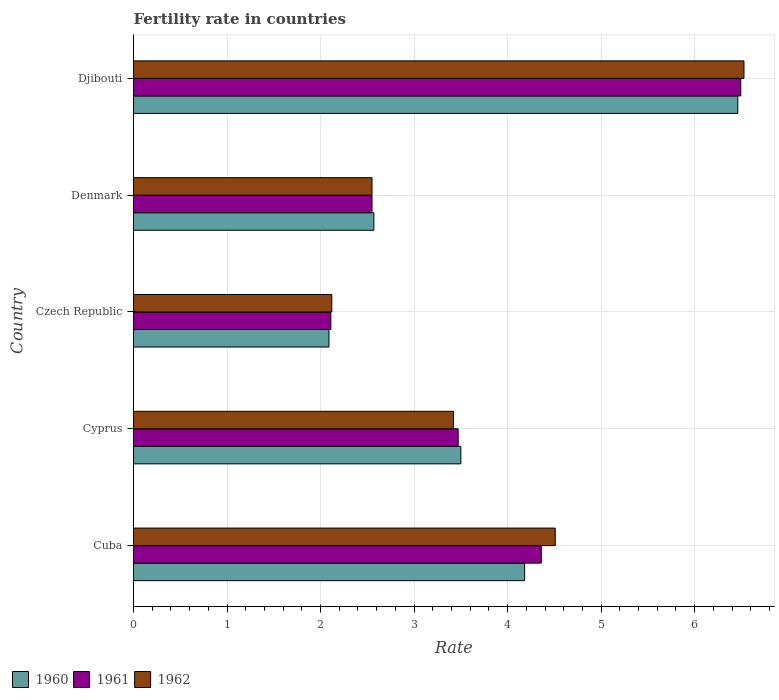Are the number of bars on each tick of the Y-axis equal?
Give a very brief answer. Yes. How many bars are there on the 5th tick from the bottom?
Make the answer very short. 3. What is the label of the 4th group of bars from the top?
Offer a very short reply. Cyprus. In how many cases, is the number of bars for a given country not equal to the number of legend labels?
Your answer should be very brief. 0. What is the fertility rate in 1960 in Cuba?
Offer a terse response. 4.18. Across all countries, what is the maximum fertility rate in 1960?
Keep it short and to the point. 6.46. Across all countries, what is the minimum fertility rate in 1962?
Your answer should be compact. 2.12. In which country was the fertility rate in 1962 maximum?
Make the answer very short. Djibouti. In which country was the fertility rate in 1962 minimum?
Keep it short and to the point. Czech Republic. What is the total fertility rate in 1962 in the graph?
Your answer should be very brief. 19.13. What is the difference between the fertility rate in 1960 in Cuba and that in Djibouti?
Your answer should be very brief. -2.28. What is the difference between the fertility rate in 1960 in Djibouti and the fertility rate in 1962 in Cyprus?
Offer a very short reply. 3.04. What is the average fertility rate in 1961 per country?
Offer a very short reply. 3.8. What is the difference between the fertility rate in 1961 and fertility rate in 1962 in Cyprus?
Give a very brief answer. 0.05. What is the ratio of the fertility rate in 1960 in Cuba to that in Denmark?
Your response must be concise. 1.63. What is the difference between the highest and the second highest fertility rate in 1962?
Keep it short and to the point. 2.02. What is the difference between the highest and the lowest fertility rate in 1960?
Offer a very short reply. 4.37. Is it the case that in every country, the sum of the fertility rate in 1960 and fertility rate in 1962 is greater than the fertility rate in 1961?
Your answer should be compact. Yes. Are all the bars in the graph horizontal?
Keep it short and to the point. Yes. Are the values on the major ticks of X-axis written in scientific E-notation?
Your response must be concise. No. Does the graph contain any zero values?
Your answer should be compact. No. How are the legend labels stacked?
Your response must be concise. Horizontal. What is the title of the graph?
Your answer should be very brief. Fertility rate in countries. What is the label or title of the X-axis?
Your answer should be very brief. Rate. What is the label or title of the Y-axis?
Your answer should be compact. Country. What is the Rate of 1960 in Cuba?
Keep it short and to the point. 4.18. What is the Rate of 1961 in Cuba?
Give a very brief answer. 4.36. What is the Rate of 1962 in Cuba?
Offer a terse response. 4.51. What is the Rate in 1960 in Cyprus?
Ensure brevity in your answer.  3.5. What is the Rate of 1961 in Cyprus?
Make the answer very short. 3.47. What is the Rate in 1962 in Cyprus?
Provide a succinct answer. 3.42. What is the Rate in 1960 in Czech Republic?
Your answer should be very brief. 2.09. What is the Rate of 1961 in Czech Republic?
Offer a terse response. 2.11. What is the Rate in 1962 in Czech Republic?
Your response must be concise. 2.12. What is the Rate of 1960 in Denmark?
Provide a succinct answer. 2.57. What is the Rate in 1961 in Denmark?
Ensure brevity in your answer.  2.55. What is the Rate of 1962 in Denmark?
Make the answer very short. 2.55. What is the Rate of 1960 in Djibouti?
Provide a succinct answer. 6.46. What is the Rate in 1961 in Djibouti?
Your response must be concise. 6.49. What is the Rate in 1962 in Djibouti?
Make the answer very short. 6.53. Across all countries, what is the maximum Rate in 1960?
Ensure brevity in your answer.  6.46. Across all countries, what is the maximum Rate in 1961?
Ensure brevity in your answer.  6.49. Across all countries, what is the maximum Rate of 1962?
Provide a short and direct response. 6.53. Across all countries, what is the minimum Rate of 1960?
Offer a very short reply. 2.09. Across all countries, what is the minimum Rate of 1961?
Provide a succinct answer. 2.11. Across all countries, what is the minimum Rate of 1962?
Offer a terse response. 2.12. What is the total Rate of 1960 in the graph?
Give a very brief answer. 18.8. What is the total Rate in 1961 in the graph?
Your response must be concise. 18.98. What is the total Rate of 1962 in the graph?
Provide a short and direct response. 19.13. What is the difference between the Rate in 1960 in Cuba and that in Cyprus?
Keep it short and to the point. 0.68. What is the difference between the Rate of 1961 in Cuba and that in Cyprus?
Give a very brief answer. 0.89. What is the difference between the Rate of 1962 in Cuba and that in Cyprus?
Give a very brief answer. 1.09. What is the difference between the Rate in 1960 in Cuba and that in Czech Republic?
Provide a succinct answer. 2.09. What is the difference between the Rate in 1961 in Cuba and that in Czech Republic?
Ensure brevity in your answer.  2.25. What is the difference between the Rate of 1962 in Cuba and that in Czech Republic?
Your answer should be compact. 2.39. What is the difference between the Rate of 1960 in Cuba and that in Denmark?
Your answer should be very brief. 1.61. What is the difference between the Rate of 1961 in Cuba and that in Denmark?
Your answer should be very brief. 1.81. What is the difference between the Rate in 1962 in Cuba and that in Denmark?
Give a very brief answer. 1.96. What is the difference between the Rate in 1960 in Cuba and that in Djibouti?
Give a very brief answer. -2.28. What is the difference between the Rate in 1961 in Cuba and that in Djibouti?
Provide a short and direct response. -2.13. What is the difference between the Rate in 1962 in Cuba and that in Djibouti?
Your answer should be very brief. -2.02. What is the difference between the Rate in 1960 in Cyprus and that in Czech Republic?
Make the answer very short. 1.41. What is the difference between the Rate of 1961 in Cyprus and that in Czech Republic?
Provide a succinct answer. 1.36. What is the difference between the Rate of 1962 in Cyprus and that in Czech Republic?
Your response must be concise. 1.3. What is the difference between the Rate of 1960 in Cyprus and that in Denmark?
Offer a very short reply. 0.93. What is the difference between the Rate in 1961 in Cyprus and that in Denmark?
Your answer should be very brief. 0.92. What is the difference between the Rate of 1962 in Cyprus and that in Denmark?
Ensure brevity in your answer.  0.87. What is the difference between the Rate in 1960 in Cyprus and that in Djibouti?
Provide a short and direct response. -2.96. What is the difference between the Rate of 1961 in Cyprus and that in Djibouti?
Offer a very short reply. -3.02. What is the difference between the Rate of 1962 in Cyprus and that in Djibouti?
Provide a short and direct response. -3.11. What is the difference between the Rate of 1960 in Czech Republic and that in Denmark?
Make the answer very short. -0.48. What is the difference between the Rate in 1961 in Czech Republic and that in Denmark?
Provide a short and direct response. -0.44. What is the difference between the Rate in 1962 in Czech Republic and that in Denmark?
Your response must be concise. -0.43. What is the difference between the Rate of 1960 in Czech Republic and that in Djibouti?
Your answer should be very brief. -4.37. What is the difference between the Rate of 1961 in Czech Republic and that in Djibouti?
Give a very brief answer. -4.38. What is the difference between the Rate in 1962 in Czech Republic and that in Djibouti?
Your answer should be very brief. -4.41. What is the difference between the Rate of 1960 in Denmark and that in Djibouti?
Make the answer very short. -3.89. What is the difference between the Rate in 1961 in Denmark and that in Djibouti?
Your answer should be very brief. -3.94. What is the difference between the Rate of 1962 in Denmark and that in Djibouti?
Your response must be concise. -3.98. What is the difference between the Rate in 1960 in Cuba and the Rate in 1961 in Cyprus?
Provide a short and direct response. 0.71. What is the difference between the Rate in 1960 in Cuba and the Rate in 1962 in Cyprus?
Offer a very short reply. 0.76. What is the difference between the Rate of 1961 in Cuba and the Rate of 1962 in Cyprus?
Your answer should be very brief. 0.94. What is the difference between the Rate in 1960 in Cuba and the Rate in 1961 in Czech Republic?
Your answer should be compact. 2.07. What is the difference between the Rate of 1960 in Cuba and the Rate of 1962 in Czech Republic?
Offer a very short reply. 2.06. What is the difference between the Rate of 1961 in Cuba and the Rate of 1962 in Czech Republic?
Provide a short and direct response. 2.24. What is the difference between the Rate in 1960 in Cuba and the Rate in 1961 in Denmark?
Offer a terse response. 1.63. What is the difference between the Rate of 1960 in Cuba and the Rate of 1962 in Denmark?
Offer a terse response. 1.63. What is the difference between the Rate in 1961 in Cuba and the Rate in 1962 in Denmark?
Offer a terse response. 1.81. What is the difference between the Rate in 1960 in Cuba and the Rate in 1961 in Djibouti?
Keep it short and to the point. -2.31. What is the difference between the Rate in 1960 in Cuba and the Rate in 1962 in Djibouti?
Give a very brief answer. -2.35. What is the difference between the Rate in 1961 in Cuba and the Rate in 1962 in Djibouti?
Give a very brief answer. -2.17. What is the difference between the Rate of 1960 in Cyprus and the Rate of 1961 in Czech Republic?
Provide a short and direct response. 1.39. What is the difference between the Rate of 1960 in Cyprus and the Rate of 1962 in Czech Republic?
Ensure brevity in your answer.  1.38. What is the difference between the Rate in 1961 in Cyprus and the Rate in 1962 in Czech Republic?
Offer a terse response. 1.35. What is the difference between the Rate in 1961 in Cyprus and the Rate in 1962 in Denmark?
Offer a terse response. 0.92. What is the difference between the Rate of 1960 in Cyprus and the Rate of 1961 in Djibouti?
Provide a succinct answer. -2.99. What is the difference between the Rate in 1960 in Cyprus and the Rate in 1962 in Djibouti?
Provide a short and direct response. -3.03. What is the difference between the Rate in 1961 in Cyprus and the Rate in 1962 in Djibouti?
Your answer should be very brief. -3.06. What is the difference between the Rate in 1960 in Czech Republic and the Rate in 1961 in Denmark?
Your response must be concise. -0.46. What is the difference between the Rate of 1960 in Czech Republic and the Rate of 1962 in Denmark?
Make the answer very short. -0.46. What is the difference between the Rate of 1961 in Czech Republic and the Rate of 1962 in Denmark?
Your response must be concise. -0.44. What is the difference between the Rate in 1960 in Czech Republic and the Rate in 1961 in Djibouti?
Provide a succinct answer. -4.4. What is the difference between the Rate of 1960 in Czech Republic and the Rate of 1962 in Djibouti?
Provide a short and direct response. -4.44. What is the difference between the Rate of 1961 in Czech Republic and the Rate of 1962 in Djibouti?
Ensure brevity in your answer.  -4.42. What is the difference between the Rate in 1960 in Denmark and the Rate in 1961 in Djibouti?
Make the answer very short. -3.92. What is the difference between the Rate of 1960 in Denmark and the Rate of 1962 in Djibouti?
Your answer should be very brief. -3.96. What is the difference between the Rate in 1961 in Denmark and the Rate in 1962 in Djibouti?
Give a very brief answer. -3.98. What is the average Rate in 1960 per country?
Offer a very short reply. 3.76. What is the average Rate in 1961 per country?
Your response must be concise. 3.8. What is the average Rate of 1962 per country?
Provide a succinct answer. 3.83. What is the difference between the Rate of 1960 and Rate of 1961 in Cuba?
Make the answer very short. -0.18. What is the difference between the Rate in 1960 and Rate in 1962 in Cuba?
Ensure brevity in your answer.  -0.33. What is the difference between the Rate of 1961 and Rate of 1962 in Cuba?
Provide a succinct answer. -0.15. What is the difference between the Rate in 1960 and Rate in 1961 in Cyprus?
Provide a succinct answer. 0.03. What is the difference between the Rate in 1960 and Rate in 1962 in Cyprus?
Offer a very short reply. 0.08. What is the difference between the Rate of 1960 and Rate of 1961 in Czech Republic?
Give a very brief answer. -0.02. What is the difference between the Rate of 1960 and Rate of 1962 in Czech Republic?
Keep it short and to the point. -0.03. What is the difference between the Rate in 1961 and Rate in 1962 in Czech Republic?
Keep it short and to the point. -0.01. What is the difference between the Rate of 1960 and Rate of 1961 in Denmark?
Provide a succinct answer. 0.02. What is the difference between the Rate in 1960 and Rate in 1962 in Denmark?
Give a very brief answer. 0.02. What is the difference between the Rate of 1960 and Rate of 1961 in Djibouti?
Your answer should be compact. -0.03. What is the difference between the Rate of 1960 and Rate of 1962 in Djibouti?
Make the answer very short. -0.07. What is the difference between the Rate of 1961 and Rate of 1962 in Djibouti?
Ensure brevity in your answer.  -0.03. What is the ratio of the Rate in 1960 in Cuba to that in Cyprus?
Your response must be concise. 1.19. What is the ratio of the Rate of 1961 in Cuba to that in Cyprus?
Give a very brief answer. 1.26. What is the ratio of the Rate in 1962 in Cuba to that in Cyprus?
Your answer should be compact. 1.32. What is the ratio of the Rate in 1960 in Cuba to that in Czech Republic?
Provide a short and direct response. 2. What is the ratio of the Rate of 1961 in Cuba to that in Czech Republic?
Make the answer very short. 2.07. What is the ratio of the Rate of 1962 in Cuba to that in Czech Republic?
Provide a succinct answer. 2.13. What is the ratio of the Rate of 1960 in Cuba to that in Denmark?
Make the answer very short. 1.63. What is the ratio of the Rate of 1961 in Cuba to that in Denmark?
Offer a terse response. 1.71. What is the ratio of the Rate in 1962 in Cuba to that in Denmark?
Your response must be concise. 1.77. What is the ratio of the Rate in 1960 in Cuba to that in Djibouti?
Provide a short and direct response. 0.65. What is the ratio of the Rate of 1961 in Cuba to that in Djibouti?
Ensure brevity in your answer.  0.67. What is the ratio of the Rate of 1962 in Cuba to that in Djibouti?
Give a very brief answer. 0.69. What is the ratio of the Rate of 1960 in Cyprus to that in Czech Republic?
Give a very brief answer. 1.67. What is the ratio of the Rate of 1961 in Cyprus to that in Czech Republic?
Offer a terse response. 1.65. What is the ratio of the Rate in 1962 in Cyprus to that in Czech Republic?
Offer a very short reply. 1.61. What is the ratio of the Rate of 1960 in Cyprus to that in Denmark?
Offer a terse response. 1.36. What is the ratio of the Rate of 1961 in Cyprus to that in Denmark?
Ensure brevity in your answer.  1.36. What is the ratio of the Rate in 1962 in Cyprus to that in Denmark?
Your answer should be compact. 1.34. What is the ratio of the Rate of 1960 in Cyprus to that in Djibouti?
Your response must be concise. 0.54. What is the ratio of the Rate of 1961 in Cyprus to that in Djibouti?
Ensure brevity in your answer.  0.53. What is the ratio of the Rate in 1962 in Cyprus to that in Djibouti?
Your answer should be very brief. 0.52. What is the ratio of the Rate in 1960 in Czech Republic to that in Denmark?
Make the answer very short. 0.81. What is the ratio of the Rate in 1961 in Czech Republic to that in Denmark?
Make the answer very short. 0.83. What is the ratio of the Rate of 1962 in Czech Republic to that in Denmark?
Ensure brevity in your answer.  0.83. What is the ratio of the Rate in 1960 in Czech Republic to that in Djibouti?
Provide a succinct answer. 0.32. What is the ratio of the Rate in 1961 in Czech Republic to that in Djibouti?
Your response must be concise. 0.33. What is the ratio of the Rate of 1962 in Czech Republic to that in Djibouti?
Give a very brief answer. 0.32. What is the ratio of the Rate of 1960 in Denmark to that in Djibouti?
Provide a short and direct response. 0.4. What is the ratio of the Rate of 1961 in Denmark to that in Djibouti?
Keep it short and to the point. 0.39. What is the ratio of the Rate in 1962 in Denmark to that in Djibouti?
Your response must be concise. 0.39. What is the difference between the highest and the second highest Rate of 1960?
Offer a terse response. 2.28. What is the difference between the highest and the second highest Rate in 1961?
Keep it short and to the point. 2.13. What is the difference between the highest and the second highest Rate in 1962?
Ensure brevity in your answer.  2.02. What is the difference between the highest and the lowest Rate in 1960?
Your answer should be compact. 4.37. What is the difference between the highest and the lowest Rate in 1961?
Provide a succinct answer. 4.38. What is the difference between the highest and the lowest Rate in 1962?
Your answer should be very brief. 4.41. 